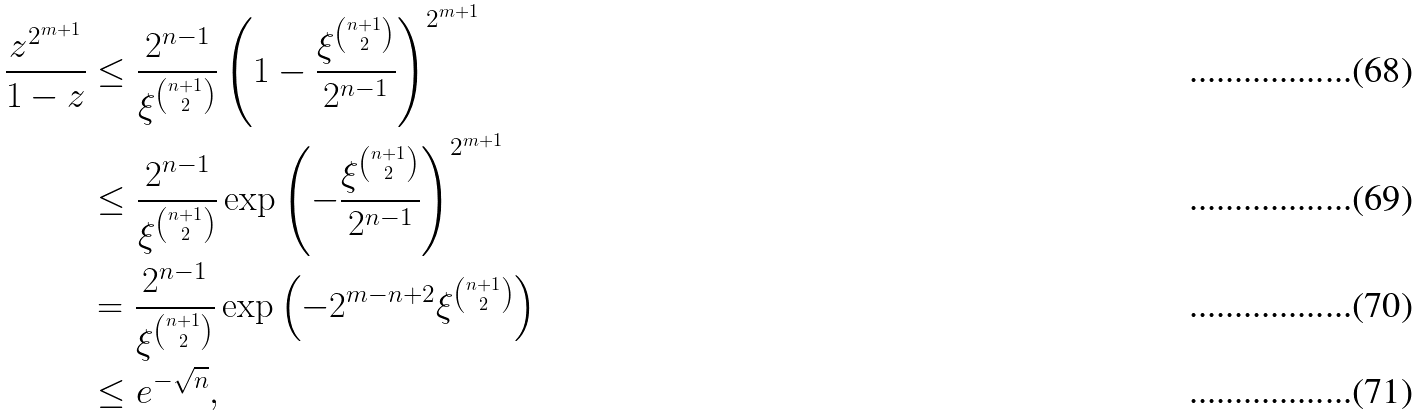Convert formula to latex. <formula><loc_0><loc_0><loc_500><loc_500>\frac { z ^ { 2 ^ { m + 1 } } } { 1 - z } & \leq \frac { 2 ^ { n - 1 } } { \xi ^ { n + 1 \choose 2 } } \left ( 1 - \frac { \xi ^ { n + 1 \choose 2 } } { 2 ^ { n - 1 } } \right ) ^ { 2 ^ { m + 1 } } \\ & \leq \frac { 2 ^ { n - 1 } } { \xi ^ { n + 1 \choose 2 } } \exp \left ( - \frac { \xi ^ { n + 1 \choose 2 } } { 2 ^ { n - 1 } } \right ) ^ { 2 ^ { m + 1 } } \\ & = \frac { 2 ^ { n - 1 } } { \xi ^ { n + 1 \choose 2 } } \exp \left ( - 2 ^ { m - n + 2 } \xi ^ { n + 1 \choose 2 } \right ) \\ & \leq e ^ { - \sqrt { n } } ,</formula> 